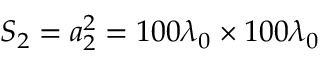Convert formula to latex. <formula><loc_0><loc_0><loc_500><loc_500>S _ { 2 } = a _ { 2 } ^ { 2 } = 1 0 0 \lambda _ { 0 } \times 1 0 0 \lambda _ { 0 }</formula> 